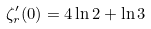<formula> <loc_0><loc_0><loc_500><loc_500>\zeta _ { r } ^ { \prime } ( 0 ) = 4 \ln 2 + \ln 3</formula> 